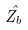Convert formula to latex. <formula><loc_0><loc_0><loc_500><loc_500>\hat { Z _ { b } }</formula> 